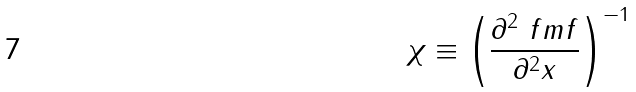Convert formula to latex. <formula><loc_0><loc_0><loc_500><loc_500>\chi \equiv \left ( \frac { \partial ^ { 2 } \ f m f } { \partial ^ { 2 } x } \right ) ^ { - 1 }</formula> 